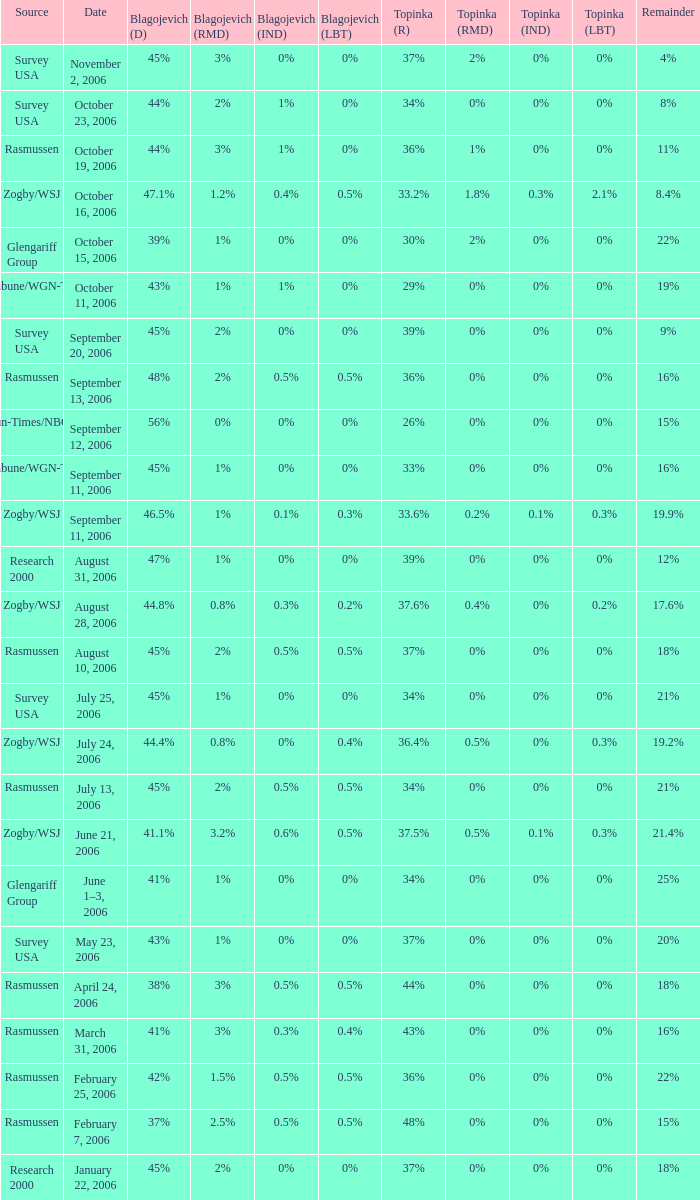Which Blagojevich (D) happened on october 16, 2006? 47.1%. 